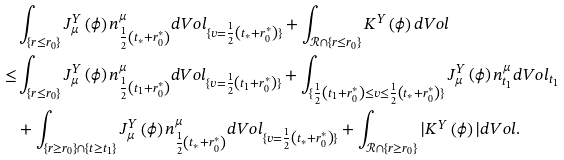<formula> <loc_0><loc_0><loc_500><loc_500>& \int _ { \{ r \leq r _ { 0 } \} } J ^ { Y } _ { \mu } \left ( \phi \right ) n ^ { \mu } _ { \frac { 1 } { 2 } \left ( t _ { * } + r _ { 0 } ^ { * } \right ) } d V o l _ { \{ v = \frac { 1 } { 2 } \left ( t _ { * } + r _ { 0 } ^ { * } \right ) \} } + \int _ { \mathcal { R } \cap \{ r \leq r _ { 0 } \} } K ^ { Y } \left ( \phi \right ) d V o l \\ \leq & \int _ { \{ r \leq r _ { 0 } \} } J ^ { Y } _ { \mu } \left ( \phi \right ) n ^ { \mu } _ { \frac { 1 } { 2 } \left ( t _ { 1 } + r _ { 0 } ^ { * } \right ) } d V o l _ { \{ v = \frac { 1 } { 2 } \left ( t _ { 1 } + r _ { 0 } ^ { * } \right ) \} } + \int _ { \{ \frac { 1 } { 2 } \left ( t _ { 1 } + r _ { 0 } ^ { * } \right ) \leq v \leq \frac { 1 } { 2 } \left ( t _ { * } + r _ { 0 } ^ { * } \right ) \} } J ^ { Y } _ { \mu } \left ( \phi \right ) n ^ { \mu } _ { t _ { 1 } } d V o l _ { t _ { 1 } } \\ & + \int _ { \{ r \geq r _ { 0 } \} \cap \{ t \geq t _ { 1 } \} } J ^ { Y } _ { \mu } \left ( \phi \right ) n ^ { \mu } _ { \frac { 1 } { 2 } \left ( t _ { * } + r _ { 0 } ^ { * } \right ) } d V o l _ { \{ v = \frac { 1 } { 2 } \left ( t _ { * } + r _ { 0 } ^ { * } \right ) \} } + \int _ { \mathcal { R } \cap \{ r \geq r _ { 0 } \} } | K ^ { Y } \left ( \phi \right ) | d V o l .</formula> 